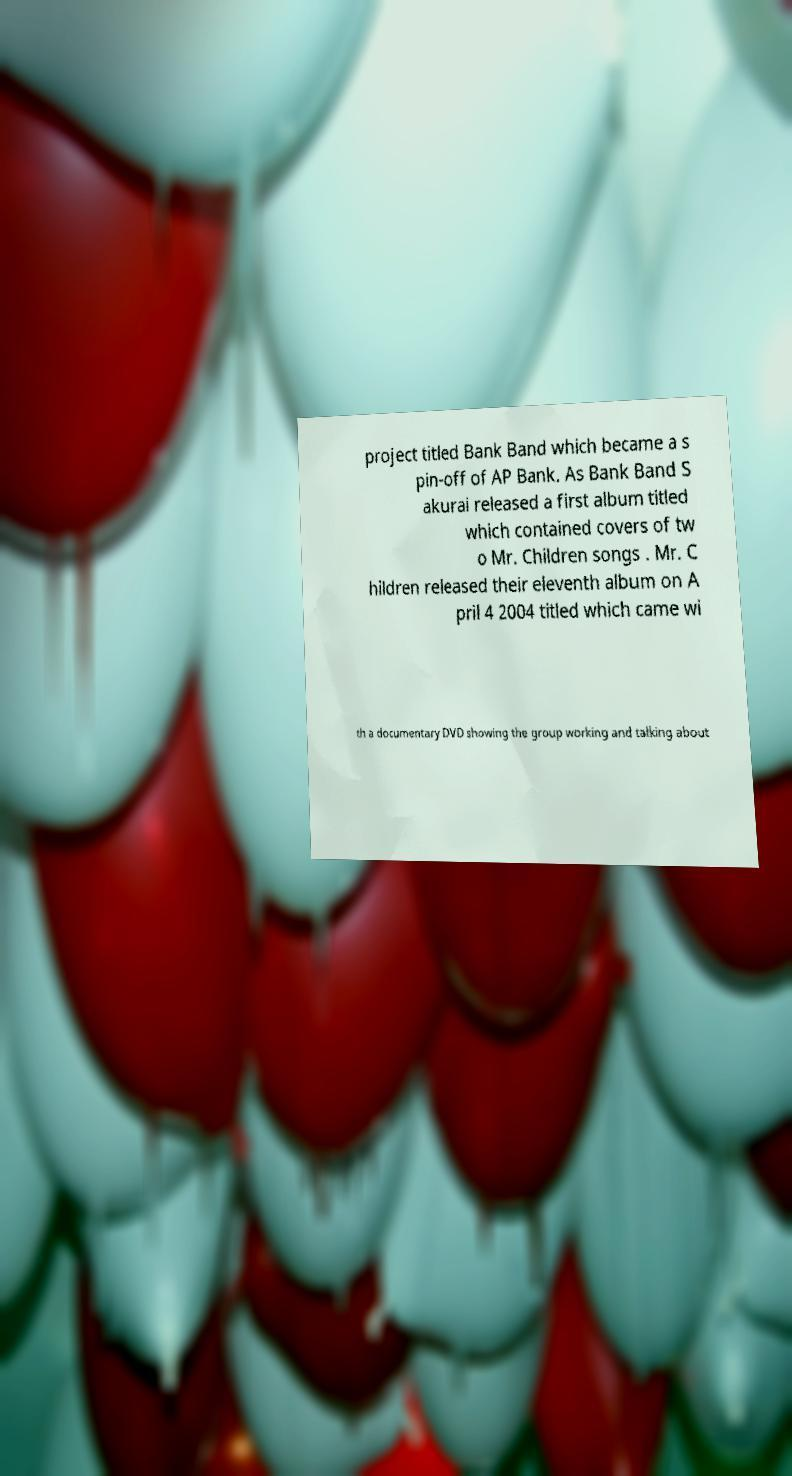Can you accurately transcribe the text from the provided image for me? project titled Bank Band which became a s pin-off of AP Bank. As Bank Band S akurai released a first album titled which contained covers of tw o Mr. Children songs . Mr. C hildren released their eleventh album on A pril 4 2004 titled which came wi th a documentary DVD showing the group working and talking about 